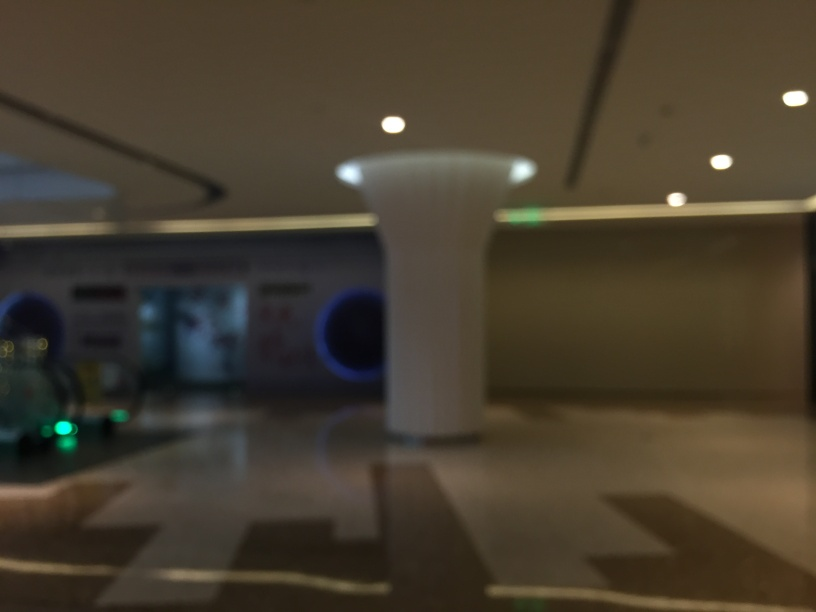Can you tell what this place might be used for? Despite the blurred quality of the image, it seems to be an indoor area, possibly a public space such as a lobby or terminal due to the presence of what could be informational signage and contrasting floor patterns that often guide foot traffic. 